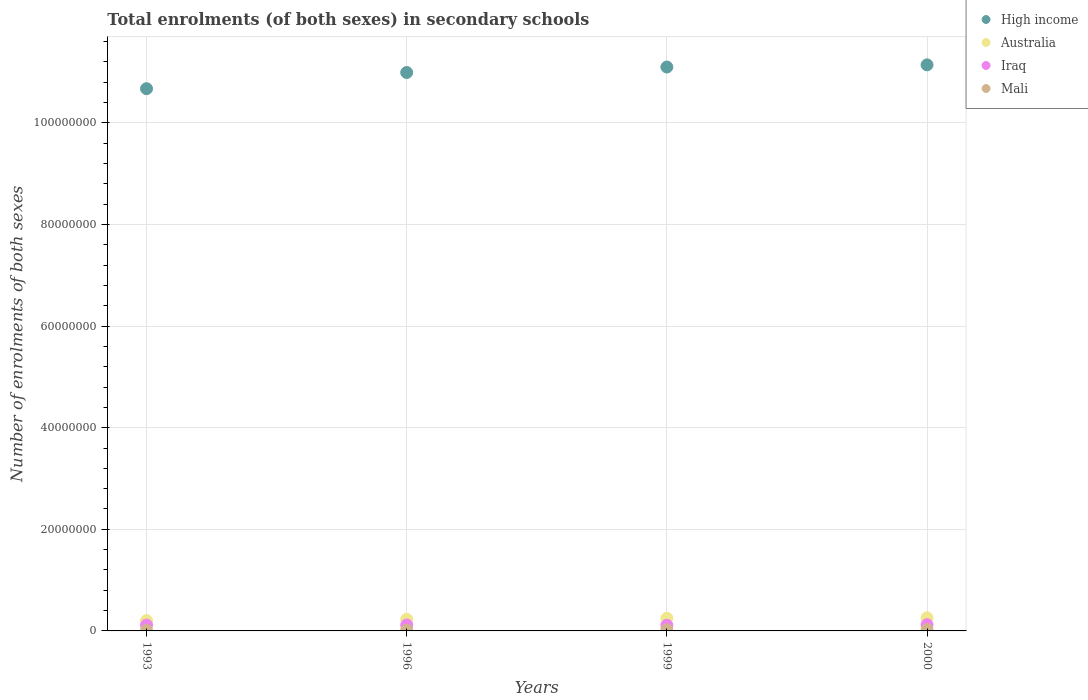What is the number of enrolments in secondary schools in Mali in 1996?
Your answer should be very brief. 1.52e+05. Across all years, what is the maximum number of enrolments in secondary schools in Iraq?
Provide a succinct answer. 1.22e+06. Across all years, what is the minimum number of enrolments in secondary schools in High income?
Your response must be concise. 1.07e+08. In which year was the number of enrolments in secondary schools in Australia minimum?
Offer a very short reply. 1993. What is the total number of enrolments in secondary schools in Australia in the graph?
Give a very brief answer. 9.39e+06. What is the difference between the number of enrolments in secondary schools in Mali in 1993 and that in 1996?
Your response must be concise. -4.88e+04. What is the difference between the number of enrolments in secondary schools in Iraq in 1999 and the number of enrolments in secondary schools in Australia in 2000?
Give a very brief answer. -1.48e+06. What is the average number of enrolments in secondary schools in Mali per year?
Ensure brevity in your answer.  1.82e+05. In the year 1999, what is the difference between the number of enrolments in secondary schools in Australia and number of enrolments in secondary schools in Iraq?
Your answer should be compact. 1.39e+06. What is the ratio of the number of enrolments in secondary schools in Mali in 1996 to that in 1999?
Ensure brevity in your answer.  0.7. Is the difference between the number of enrolments in secondary schools in Australia in 1993 and 2000 greater than the difference between the number of enrolments in secondary schools in Iraq in 1993 and 2000?
Your response must be concise. No. What is the difference between the highest and the second highest number of enrolments in secondary schools in Iraq?
Give a very brief answer. 6.38e+04. What is the difference between the highest and the lowest number of enrolments in secondary schools in Mali?
Provide a succinct answer. 1.55e+05. Is the sum of the number of enrolments in secondary schools in High income in 1993 and 2000 greater than the maximum number of enrolments in secondary schools in Iraq across all years?
Give a very brief answer. Yes. How many dotlines are there?
Provide a succinct answer. 4. What is the difference between two consecutive major ticks on the Y-axis?
Offer a terse response. 2.00e+07. Are the values on the major ticks of Y-axis written in scientific E-notation?
Make the answer very short. No. Does the graph contain any zero values?
Give a very brief answer. No. Does the graph contain grids?
Provide a short and direct response. Yes. Where does the legend appear in the graph?
Offer a terse response. Top right. What is the title of the graph?
Offer a very short reply. Total enrolments (of both sexes) in secondary schools. What is the label or title of the Y-axis?
Your response must be concise. Number of enrolments of both sexes. What is the Number of enrolments of both sexes of High income in 1993?
Make the answer very short. 1.07e+08. What is the Number of enrolments of both sexes of Australia in 1993?
Offer a very short reply. 2.03e+06. What is the Number of enrolments of both sexes of Iraq in 1993?
Provide a succinct answer. 1.14e+06. What is the Number of enrolments of both sexes of Mali in 1993?
Provide a succinct answer. 1.03e+05. What is the Number of enrolments of both sexes in High income in 1996?
Provide a succinct answer. 1.10e+08. What is the Number of enrolments of both sexes in Australia in 1996?
Ensure brevity in your answer.  2.28e+06. What is the Number of enrolments of both sexes in Iraq in 1996?
Your answer should be compact. 1.16e+06. What is the Number of enrolments of both sexes of Mali in 1996?
Make the answer very short. 1.52e+05. What is the Number of enrolments of both sexes of High income in 1999?
Ensure brevity in your answer.  1.11e+08. What is the Number of enrolments of both sexes in Australia in 1999?
Your response must be concise. 2.49e+06. What is the Number of enrolments of both sexes in Iraq in 1999?
Your response must be concise. 1.11e+06. What is the Number of enrolments of both sexes in Mali in 1999?
Give a very brief answer. 2.18e+05. What is the Number of enrolments of both sexes in High income in 2000?
Your answer should be very brief. 1.11e+08. What is the Number of enrolments of both sexes of Australia in 2000?
Provide a short and direct response. 2.59e+06. What is the Number of enrolments of both sexes of Iraq in 2000?
Your answer should be very brief. 1.22e+06. What is the Number of enrolments of both sexes in Mali in 2000?
Provide a short and direct response. 2.58e+05. Across all years, what is the maximum Number of enrolments of both sexes in High income?
Ensure brevity in your answer.  1.11e+08. Across all years, what is the maximum Number of enrolments of both sexes of Australia?
Offer a terse response. 2.59e+06. Across all years, what is the maximum Number of enrolments of both sexes in Iraq?
Your answer should be very brief. 1.22e+06. Across all years, what is the maximum Number of enrolments of both sexes of Mali?
Provide a succinct answer. 2.58e+05. Across all years, what is the minimum Number of enrolments of both sexes of High income?
Provide a short and direct response. 1.07e+08. Across all years, what is the minimum Number of enrolments of both sexes in Australia?
Your response must be concise. 2.03e+06. Across all years, what is the minimum Number of enrolments of both sexes of Iraq?
Your response must be concise. 1.11e+06. Across all years, what is the minimum Number of enrolments of both sexes in Mali?
Give a very brief answer. 1.03e+05. What is the total Number of enrolments of both sexes of High income in the graph?
Your answer should be very brief. 4.39e+08. What is the total Number of enrolments of both sexes of Australia in the graph?
Make the answer very short. 9.39e+06. What is the total Number of enrolments of both sexes of Iraq in the graph?
Provide a short and direct response. 4.63e+06. What is the total Number of enrolments of both sexes in Mali in the graph?
Provide a short and direct response. 7.30e+05. What is the difference between the Number of enrolments of both sexes in High income in 1993 and that in 1996?
Your answer should be compact. -3.19e+06. What is the difference between the Number of enrolments of both sexes in Australia in 1993 and that in 1996?
Offer a very short reply. -2.51e+05. What is the difference between the Number of enrolments of both sexes of Iraq in 1993 and that in 1996?
Make the answer very short. -1.55e+04. What is the difference between the Number of enrolments of both sexes of Mali in 1993 and that in 1996?
Provide a short and direct response. -4.88e+04. What is the difference between the Number of enrolments of both sexes of High income in 1993 and that in 1999?
Your answer should be very brief. -4.27e+06. What is the difference between the Number of enrolments of both sexes of Australia in 1993 and that in 1999?
Your answer should be very brief. -4.62e+05. What is the difference between the Number of enrolments of both sexes in Iraq in 1993 and that in 1999?
Make the answer very short. 3.99e+04. What is the difference between the Number of enrolments of both sexes in Mali in 1993 and that in 1999?
Make the answer very short. -1.15e+05. What is the difference between the Number of enrolments of both sexes of High income in 1993 and that in 2000?
Your answer should be compact. -4.69e+06. What is the difference between the Number of enrolments of both sexes in Australia in 1993 and that in 2000?
Your response must be concise. -5.60e+05. What is the difference between the Number of enrolments of both sexes of Iraq in 1993 and that in 2000?
Keep it short and to the point. -7.93e+04. What is the difference between the Number of enrolments of both sexes of Mali in 1993 and that in 2000?
Your answer should be compact. -1.55e+05. What is the difference between the Number of enrolments of both sexes in High income in 1996 and that in 1999?
Keep it short and to the point. -1.08e+06. What is the difference between the Number of enrolments of both sexes in Australia in 1996 and that in 1999?
Your answer should be compact. -2.11e+05. What is the difference between the Number of enrolments of both sexes in Iraq in 1996 and that in 1999?
Offer a very short reply. 5.54e+04. What is the difference between the Number of enrolments of both sexes in Mali in 1996 and that in 1999?
Offer a very short reply. -6.61e+04. What is the difference between the Number of enrolments of both sexes of High income in 1996 and that in 2000?
Ensure brevity in your answer.  -1.51e+06. What is the difference between the Number of enrolments of both sexes of Australia in 1996 and that in 2000?
Your answer should be compact. -3.09e+05. What is the difference between the Number of enrolments of both sexes in Iraq in 1996 and that in 2000?
Keep it short and to the point. -6.38e+04. What is the difference between the Number of enrolments of both sexes in Mali in 1996 and that in 2000?
Provide a short and direct response. -1.06e+05. What is the difference between the Number of enrolments of both sexes in High income in 1999 and that in 2000?
Your response must be concise. -4.26e+05. What is the difference between the Number of enrolments of both sexes of Australia in 1999 and that in 2000?
Make the answer very short. -9.81e+04. What is the difference between the Number of enrolments of both sexes of Iraq in 1999 and that in 2000?
Provide a succinct answer. -1.19e+05. What is the difference between the Number of enrolments of both sexes of Mali in 1999 and that in 2000?
Ensure brevity in your answer.  -4.01e+04. What is the difference between the Number of enrolments of both sexes in High income in 1993 and the Number of enrolments of both sexes in Australia in 1996?
Make the answer very short. 1.04e+08. What is the difference between the Number of enrolments of both sexes in High income in 1993 and the Number of enrolments of both sexes in Iraq in 1996?
Provide a succinct answer. 1.06e+08. What is the difference between the Number of enrolments of both sexes of High income in 1993 and the Number of enrolments of both sexes of Mali in 1996?
Make the answer very short. 1.07e+08. What is the difference between the Number of enrolments of both sexes of Australia in 1993 and the Number of enrolments of both sexes of Iraq in 1996?
Make the answer very short. 8.69e+05. What is the difference between the Number of enrolments of both sexes in Australia in 1993 and the Number of enrolments of both sexes in Mali in 1996?
Give a very brief answer. 1.88e+06. What is the difference between the Number of enrolments of both sexes in Iraq in 1993 and the Number of enrolments of both sexes in Mali in 1996?
Keep it short and to the point. 9.93e+05. What is the difference between the Number of enrolments of both sexes in High income in 1993 and the Number of enrolments of both sexes in Australia in 1999?
Your response must be concise. 1.04e+08. What is the difference between the Number of enrolments of both sexes of High income in 1993 and the Number of enrolments of both sexes of Iraq in 1999?
Offer a very short reply. 1.06e+08. What is the difference between the Number of enrolments of both sexes of High income in 1993 and the Number of enrolments of both sexes of Mali in 1999?
Offer a terse response. 1.06e+08. What is the difference between the Number of enrolments of both sexes in Australia in 1993 and the Number of enrolments of both sexes in Iraq in 1999?
Offer a very short reply. 9.24e+05. What is the difference between the Number of enrolments of both sexes of Australia in 1993 and the Number of enrolments of both sexes of Mali in 1999?
Offer a terse response. 1.81e+06. What is the difference between the Number of enrolments of both sexes of Iraq in 1993 and the Number of enrolments of both sexes of Mali in 1999?
Give a very brief answer. 9.27e+05. What is the difference between the Number of enrolments of both sexes in High income in 1993 and the Number of enrolments of both sexes in Australia in 2000?
Offer a terse response. 1.04e+08. What is the difference between the Number of enrolments of both sexes in High income in 1993 and the Number of enrolments of both sexes in Iraq in 2000?
Give a very brief answer. 1.05e+08. What is the difference between the Number of enrolments of both sexes in High income in 1993 and the Number of enrolments of both sexes in Mali in 2000?
Make the answer very short. 1.06e+08. What is the difference between the Number of enrolments of both sexes in Australia in 1993 and the Number of enrolments of both sexes in Iraq in 2000?
Offer a very short reply. 8.05e+05. What is the difference between the Number of enrolments of both sexes in Australia in 1993 and the Number of enrolments of both sexes in Mali in 2000?
Ensure brevity in your answer.  1.77e+06. What is the difference between the Number of enrolments of both sexes of Iraq in 1993 and the Number of enrolments of both sexes of Mali in 2000?
Make the answer very short. 8.87e+05. What is the difference between the Number of enrolments of both sexes in High income in 1996 and the Number of enrolments of both sexes in Australia in 1999?
Provide a succinct answer. 1.07e+08. What is the difference between the Number of enrolments of both sexes of High income in 1996 and the Number of enrolments of both sexes of Iraq in 1999?
Offer a terse response. 1.09e+08. What is the difference between the Number of enrolments of both sexes in High income in 1996 and the Number of enrolments of both sexes in Mali in 1999?
Offer a terse response. 1.10e+08. What is the difference between the Number of enrolments of both sexes of Australia in 1996 and the Number of enrolments of both sexes of Iraq in 1999?
Keep it short and to the point. 1.18e+06. What is the difference between the Number of enrolments of both sexes in Australia in 1996 and the Number of enrolments of both sexes in Mali in 1999?
Ensure brevity in your answer.  2.06e+06. What is the difference between the Number of enrolments of both sexes in Iraq in 1996 and the Number of enrolments of both sexes in Mali in 1999?
Offer a terse response. 9.43e+05. What is the difference between the Number of enrolments of both sexes in High income in 1996 and the Number of enrolments of both sexes in Australia in 2000?
Ensure brevity in your answer.  1.07e+08. What is the difference between the Number of enrolments of both sexes in High income in 1996 and the Number of enrolments of both sexes in Iraq in 2000?
Provide a short and direct response. 1.09e+08. What is the difference between the Number of enrolments of both sexes in High income in 1996 and the Number of enrolments of both sexes in Mali in 2000?
Offer a terse response. 1.10e+08. What is the difference between the Number of enrolments of both sexes of Australia in 1996 and the Number of enrolments of both sexes of Iraq in 2000?
Keep it short and to the point. 1.06e+06. What is the difference between the Number of enrolments of both sexes in Australia in 1996 and the Number of enrolments of both sexes in Mali in 2000?
Your answer should be compact. 2.02e+06. What is the difference between the Number of enrolments of both sexes of Iraq in 1996 and the Number of enrolments of both sexes of Mali in 2000?
Provide a succinct answer. 9.03e+05. What is the difference between the Number of enrolments of both sexes in High income in 1999 and the Number of enrolments of both sexes in Australia in 2000?
Provide a short and direct response. 1.08e+08. What is the difference between the Number of enrolments of both sexes of High income in 1999 and the Number of enrolments of both sexes of Iraq in 2000?
Keep it short and to the point. 1.10e+08. What is the difference between the Number of enrolments of both sexes of High income in 1999 and the Number of enrolments of both sexes of Mali in 2000?
Make the answer very short. 1.11e+08. What is the difference between the Number of enrolments of both sexes of Australia in 1999 and the Number of enrolments of both sexes of Iraq in 2000?
Your response must be concise. 1.27e+06. What is the difference between the Number of enrolments of both sexes in Australia in 1999 and the Number of enrolments of both sexes in Mali in 2000?
Offer a terse response. 2.23e+06. What is the difference between the Number of enrolments of both sexes of Iraq in 1999 and the Number of enrolments of both sexes of Mali in 2000?
Keep it short and to the point. 8.47e+05. What is the average Number of enrolments of both sexes in High income per year?
Keep it short and to the point. 1.10e+08. What is the average Number of enrolments of both sexes of Australia per year?
Make the answer very short. 2.35e+06. What is the average Number of enrolments of both sexes of Iraq per year?
Keep it short and to the point. 1.16e+06. What is the average Number of enrolments of both sexes in Mali per year?
Your answer should be very brief. 1.82e+05. In the year 1993, what is the difference between the Number of enrolments of both sexes in High income and Number of enrolments of both sexes in Australia?
Provide a short and direct response. 1.05e+08. In the year 1993, what is the difference between the Number of enrolments of both sexes in High income and Number of enrolments of both sexes in Iraq?
Your response must be concise. 1.06e+08. In the year 1993, what is the difference between the Number of enrolments of both sexes in High income and Number of enrolments of both sexes in Mali?
Make the answer very short. 1.07e+08. In the year 1993, what is the difference between the Number of enrolments of both sexes in Australia and Number of enrolments of both sexes in Iraq?
Your response must be concise. 8.84e+05. In the year 1993, what is the difference between the Number of enrolments of both sexes of Australia and Number of enrolments of both sexes of Mali?
Make the answer very short. 1.93e+06. In the year 1993, what is the difference between the Number of enrolments of both sexes in Iraq and Number of enrolments of both sexes in Mali?
Ensure brevity in your answer.  1.04e+06. In the year 1996, what is the difference between the Number of enrolments of both sexes in High income and Number of enrolments of both sexes in Australia?
Your response must be concise. 1.08e+08. In the year 1996, what is the difference between the Number of enrolments of both sexes of High income and Number of enrolments of both sexes of Iraq?
Your answer should be very brief. 1.09e+08. In the year 1996, what is the difference between the Number of enrolments of both sexes of High income and Number of enrolments of both sexes of Mali?
Offer a very short reply. 1.10e+08. In the year 1996, what is the difference between the Number of enrolments of both sexes in Australia and Number of enrolments of both sexes in Iraq?
Offer a terse response. 1.12e+06. In the year 1996, what is the difference between the Number of enrolments of both sexes in Australia and Number of enrolments of both sexes in Mali?
Your answer should be compact. 2.13e+06. In the year 1996, what is the difference between the Number of enrolments of both sexes of Iraq and Number of enrolments of both sexes of Mali?
Your answer should be compact. 1.01e+06. In the year 1999, what is the difference between the Number of enrolments of both sexes of High income and Number of enrolments of both sexes of Australia?
Provide a succinct answer. 1.08e+08. In the year 1999, what is the difference between the Number of enrolments of both sexes of High income and Number of enrolments of both sexes of Iraq?
Your response must be concise. 1.10e+08. In the year 1999, what is the difference between the Number of enrolments of both sexes of High income and Number of enrolments of both sexes of Mali?
Make the answer very short. 1.11e+08. In the year 1999, what is the difference between the Number of enrolments of both sexes of Australia and Number of enrolments of both sexes of Iraq?
Provide a succinct answer. 1.39e+06. In the year 1999, what is the difference between the Number of enrolments of both sexes of Australia and Number of enrolments of both sexes of Mali?
Provide a short and direct response. 2.27e+06. In the year 1999, what is the difference between the Number of enrolments of both sexes of Iraq and Number of enrolments of both sexes of Mali?
Make the answer very short. 8.87e+05. In the year 2000, what is the difference between the Number of enrolments of both sexes of High income and Number of enrolments of both sexes of Australia?
Offer a very short reply. 1.09e+08. In the year 2000, what is the difference between the Number of enrolments of both sexes in High income and Number of enrolments of both sexes in Iraq?
Ensure brevity in your answer.  1.10e+08. In the year 2000, what is the difference between the Number of enrolments of both sexes of High income and Number of enrolments of both sexes of Mali?
Provide a short and direct response. 1.11e+08. In the year 2000, what is the difference between the Number of enrolments of both sexes of Australia and Number of enrolments of both sexes of Iraq?
Your answer should be compact. 1.37e+06. In the year 2000, what is the difference between the Number of enrolments of both sexes of Australia and Number of enrolments of both sexes of Mali?
Your answer should be very brief. 2.33e+06. In the year 2000, what is the difference between the Number of enrolments of both sexes of Iraq and Number of enrolments of both sexes of Mali?
Your response must be concise. 9.66e+05. What is the ratio of the Number of enrolments of both sexes of Australia in 1993 to that in 1996?
Offer a terse response. 0.89. What is the ratio of the Number of enrolments of both sexes of Iraq in 1993 to that in 1996?
Provide a succinct answer. 0.99. What is the ratio of the Number of enrolments of both sexes of Mali in 1993 to that in 1996?
Your answer should be compact. 0.68. What is the ratio of the Number of enrolments of both sexes in High income in 1993 to that in 1999?
Make the answer very short. 0.96. What is the ratio of the Number of enrolments of both sexes in Australia in 1993 to that in 1999?
Provide a short and direct response. 0.81. What is the ratio of the Number of enrolments of both sexes in Iraq in 1993 to that in 1999?
Offer a very short reply. 1.04. What is the ratio of the Number of enrolments of both sexes of Mali in 1993 to that in 1999?
Ensure brevity in your answer.  0.47. What is the ratio of the Number of enrolments of both sexes in High income in 1993 to that in 2000?
Offer a very short reply. 0.96. What is the ratio of the Number of enrolments of both sexes of Australia in 1993 to that in 2000?
Your answer should be compact. 0.78. What is the ratio of the Number of enrolments of both sexes of Iraq in 1993 to that in 2000?
Ensure brevity in your answer.  0.94. What is the ratio of the Number of enrolments of both sexes of Mali in 1993 to that in 2000?
Provide a short and direct response. 0.4. What is the ratio of the Number of enrolments of both sexes in High income in 1996 to that in 1999?
Offer a very short reply. 0.99. What is the ratio of the Number of enrolments of both sexes of Australia in 1996 to that in 1999?
Keep it short and to the point. 0.92. What is the ratio of the Number of enrolments of both sexes of Iraq in 1996 to that in 1999?
Your answer should be compact. 1.05. What is the ratio of the Number of enrolments of both sexes of Mali in 1996 to that in 1999?
Make the answer very short. 0.7. What is the ratio of the Number of enrolments of both sexes of High income in 1996 to that in 2000?
Keep it short and to the point. 0.99. What is the ratio of the Number of enrolments of both sexes of Australia in 1996 to that in 2000?
Ensure brevity in your answer.  0.88. What is the ratio of the Number of enrolments of both sexes in Iraq in 1996 to that in 2000?
Provide a succinct answer. 0.95. What is the ratio of the Number of enrolments of both sexes in Mali in 1996 to that in 2000?
Give a very brief answer. 0.59. What is the ratio of the Number of enrolments of both sexes of Australia in 1999 to that in 2000?
Your answer should be compact. 0.96. What is the ratio of the Number of enrolments of both sexes of Iraq in 1999 to that in 2000?
Offer a terse response. 0.9. What is the ratio of the Number of enrolments of both sexes in Mali in 1999 to that in 2000?
Keep it short and to the point. 0.84. What is the difference between the highest and the second highest Number of enrolments of both sexes in High income?
Keep it short and to the point. 4.26e+05. What is the difference between the highest and the second highest Number of enrolments of both sexes in Australia?
Offer a terse response. 9.81e+04. What is the difference between the highest and the second highest Number of enrolments of both sexes in Iraq?
Ensure brevity in your answer.  6.38e+04. What is the difference between the highest and the second highest Number of enrolments of both sexes of Mali?
Ensure brevity in your answer.  4.01e+04. What is the difference between the highest and the lowest Number of enrolments of both sexes in High income?
Provide a succinct answer. 4.69e+06. What is the difference between the highest and the lowest Number of enrolments of both sexes of Australia?
Offer a terse response. 5.60e+05. What is the difference between the highest and the lowest Number of enrolments of both sexes of Iraq?
Offer a terse response. 1.19e+05. What is the difference between the highest and the lowest Number of enrolments of both sexes of Mali?
Your response must be concise. 1.55e+05. 